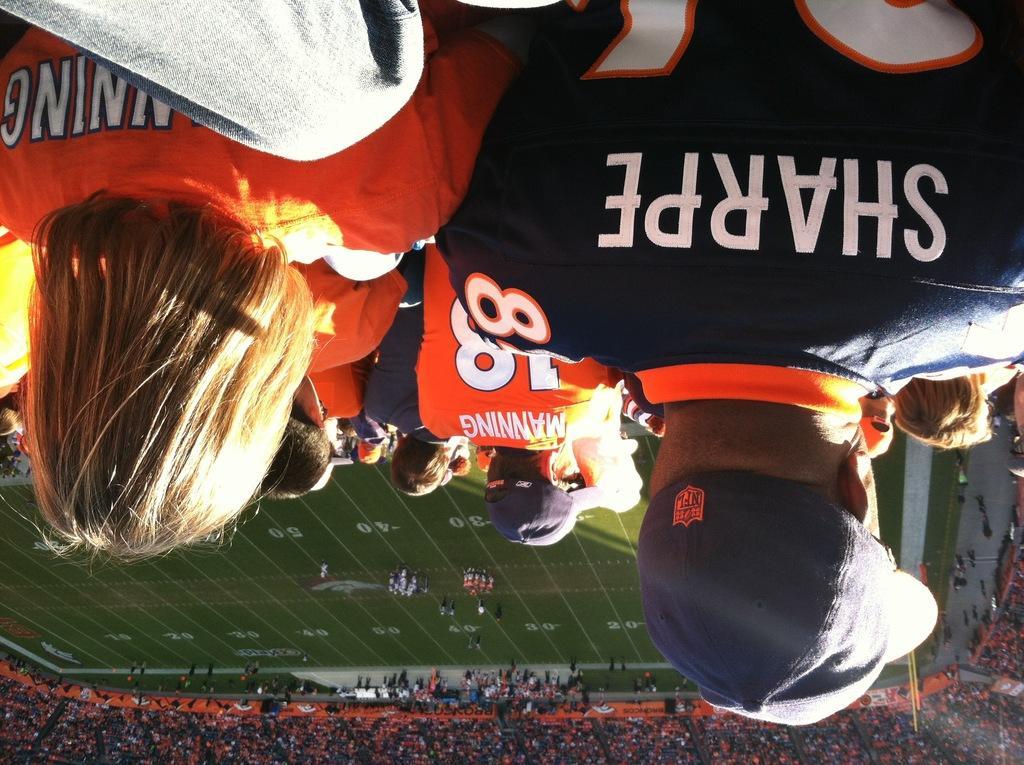Describe this image in one or two sentences. In this picture I can see a group of people at the top, in the middle few persons are playing in the ground. At the bottom I can see a lot of people, it looks like stadium. 